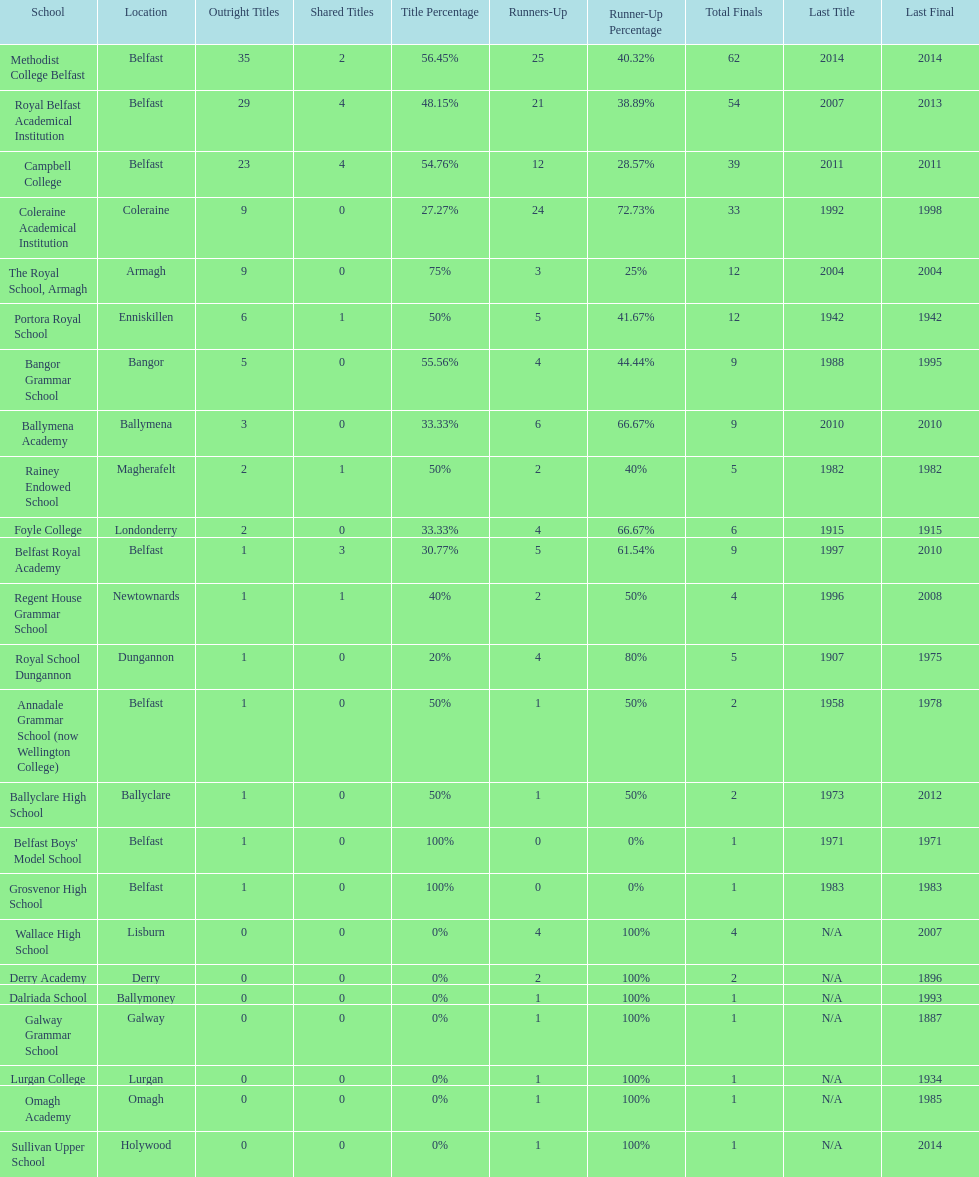What were all of the school names? Methodist College Belfast, Royal Belfast Academical Institution, Campbell College, Coleraine Academical Institution, The Royal School, Armagh, Portora Royal School, Bangor Grammar School, Ballymena Academy, Rainey Endowed School, Foyle College, Belfast Royal Academy, Regent House Grammar School, Royal School Dungannon, Annadale Grammar School (now Wellington College), Ballyclare High School, Belfast Boys' Model School, Grosvenor High School, Wallace High School, Derry Academy, Dalriada School, Galway Grammar School, Lurgan College, Omagh Academy, Sullivan Upper School. How many outright titles did they achieve? 35, 29, 23, 9, 9, 6, 5, 3, 2, 2, 1, 1, 1, 1, 1, 1, 1, 0, 0, 0, 0, 0, 0, 0. And how many did coleraine academical institution receive? 9. Which other school had the same number of outright titles? The Royal School, Armagh. 